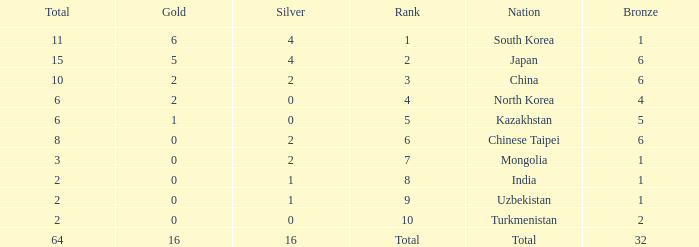Can you parse all the data within this table? {'header': ['Total', 'Gold', 'Silver', 'Rank', 'Nation', 'Bronze'], 'rows': [['11', '6', '4', '1', 'South Korea', '1'], ['15', '5', '4', '2', 'Japan', '6'], ['10', '2', '2', '3', 'China', '6'], ['6', '2', '0', '4', 'North Korea', '4'], ['6', '1', '0', '5', 'Kazakhstan', '5'], ['8', '0', '2', '6', 'Chinese Taipei', '6'], ['3', '0', '2', '7', 'Mongolia', '1'], ['2', '0', '1', '8', 'India', '1'], ['2', '0', '1', '9', 'Uzbekistan', '1'], ['2', '0', '0', '10', 'Turkmenistan', '2'], ['64', '16', '16', 'Total', 'Total', '32']]} What's the biggest Bronze that has less than 0 Silvers? None. 